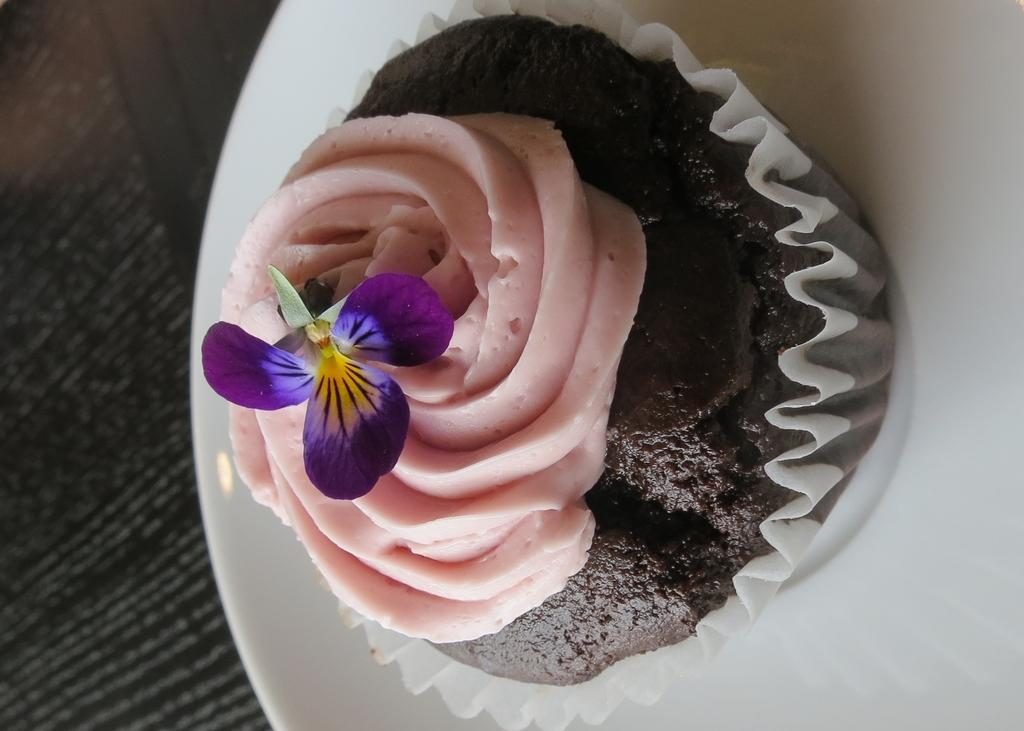What is on the plate that is visible in the image? There is a cupcake on the plate. What decoration is on the cupcake? The cupcake has a flower on it. Where is the plate located in the image? The plate is placed on a platform. Can you tell me how the window affects the temper of the cupcake in the image? There is no window present in the image, and the temper of the cupcake is not mentioned or affected by any window. 